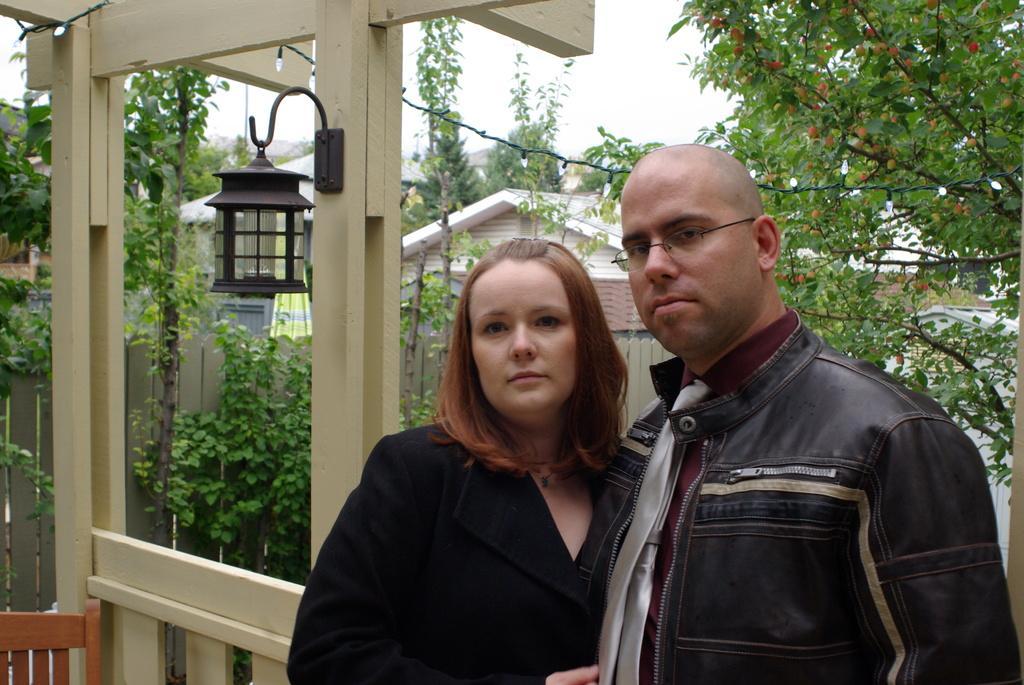Could you give a brief overview of what you see in this image? In the image we can see there are people standing and behind there are trees and buildings. 